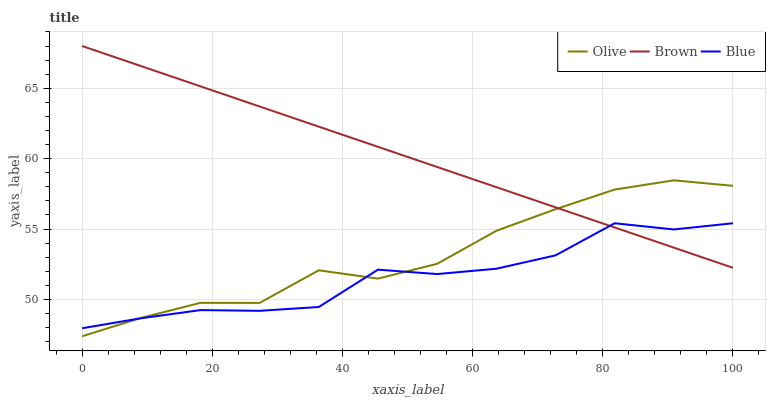Does Blue have the minimum area under the curve?
Answer yes or no. Yes. Does Brown have the maximum area under the curve?
Answer yes or no. Yes. Does Brown have the minimum area under the curve?
Answer yes or no. No. Does Blue have the maximum area under the curve?
Answer yes or no. No. Is Brown the smoothest?
Answer yes or no. Yes. Is Blue the roughest?
Answer yes or no. Yes. Is Blue the smoothest?
Answer yes or no. No. Is Brown the roughest?
Answer yes or no. No. Does Olive have the lowest value?
Answer yes or no. Yes. Does Blue have the lowest value?
Answer yes or no. No. Does Brown have the highest value?
Answer yes or no. Yes. Does Blue have the highest value?
Answer yes or no. No. Does Olive intersect Brown?
Answer yes or no. Yes. Is Olive less than Brown?
Answer yes or no. No. Is Olive greater than Brown?
Answer yes or no. No. 